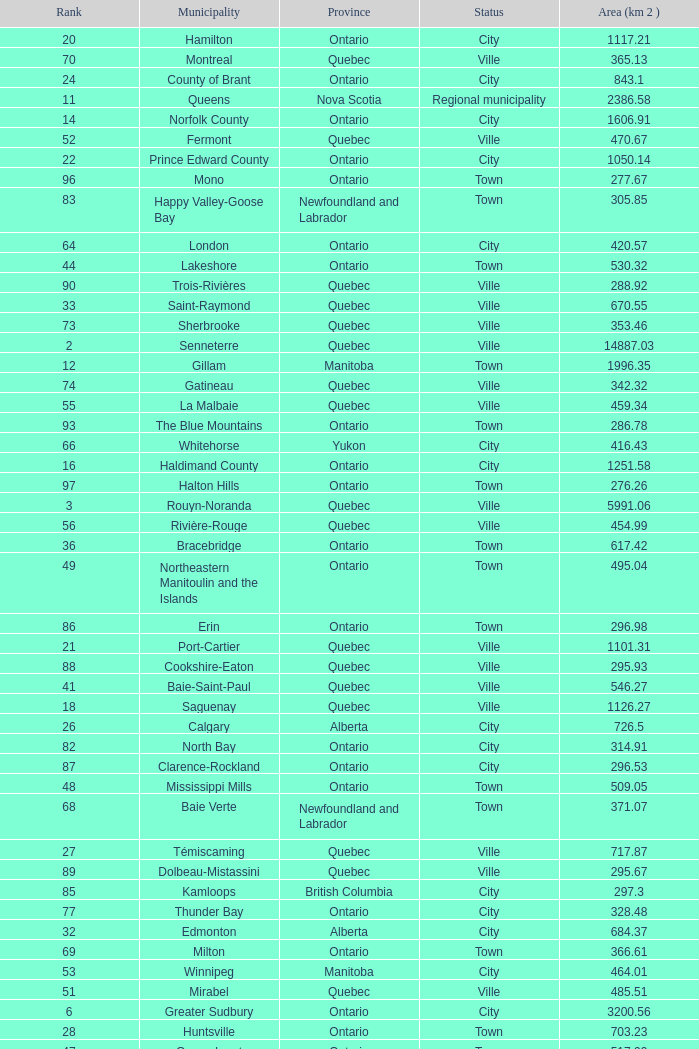What is the total Rank that has a Municipality of Winnipeg, an Area (KM 2) that's larger than 464.01? None. 